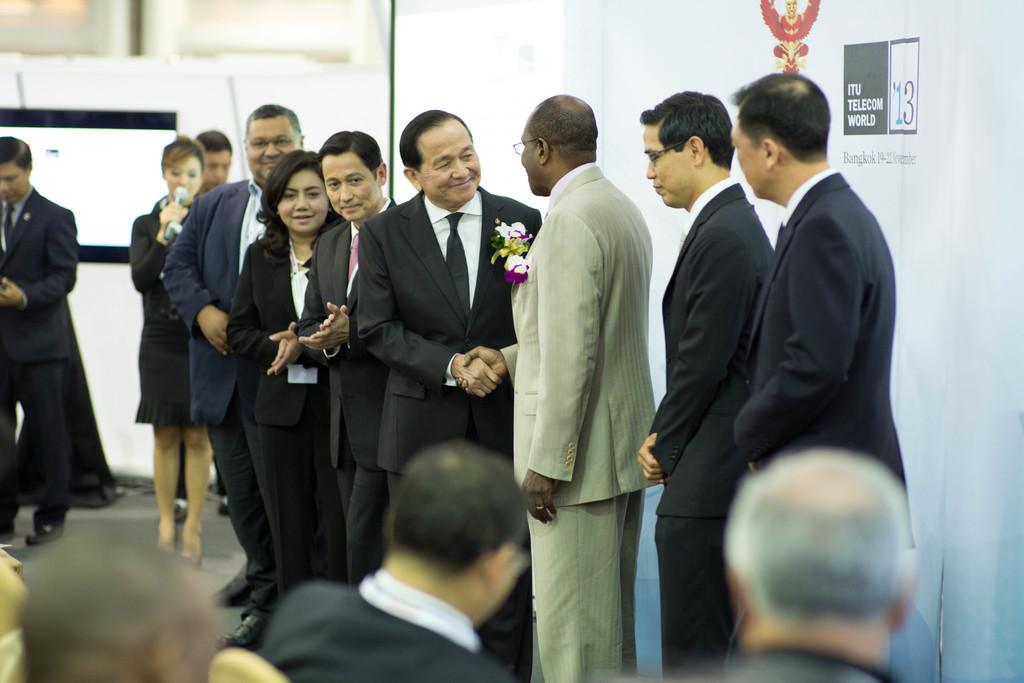What is located in the foreground of the picture? There are people and chairs in the foreground of the picture. What are the people in the foreground doing? The people in the foreground are sitting on the chairs. What can be seen in the center of the picture? There are people standing in the center of the picture. How would you describe the background of the image? The background of the image is blurred. Can you see a playground in the background of the image? There is no playground visible in the image; the background is blurred. What type of nose can be seen on the person standing in the center of the image? There is no nose visible on the person standing in the center of the image, as the image does not show any facial features. 